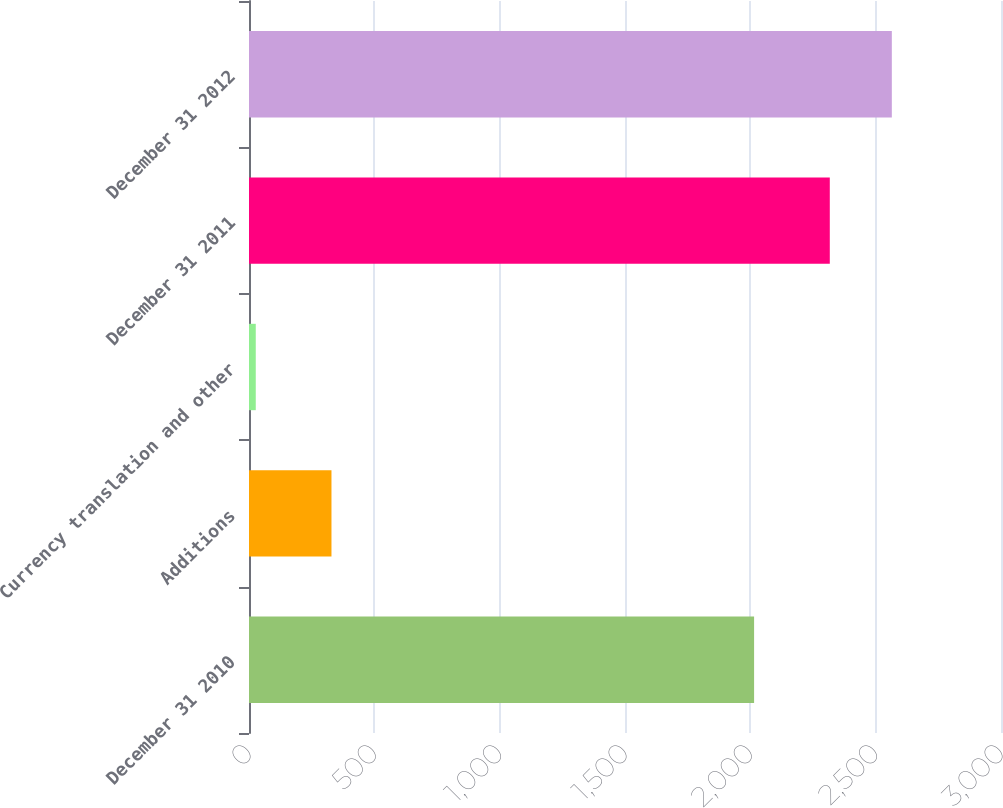<chart> <loc_0><loc_0><loc_500><loc_500><bar_chart><fcel>December 31 2010<fcel>Additions<fcel>Currency translation and other<fcel>December 31 2011<fcel>December 31 2012<nl><fcel>2015<fcel>329<fcel>27<fcel>2317<fcel>2564.5<nl></chart> 